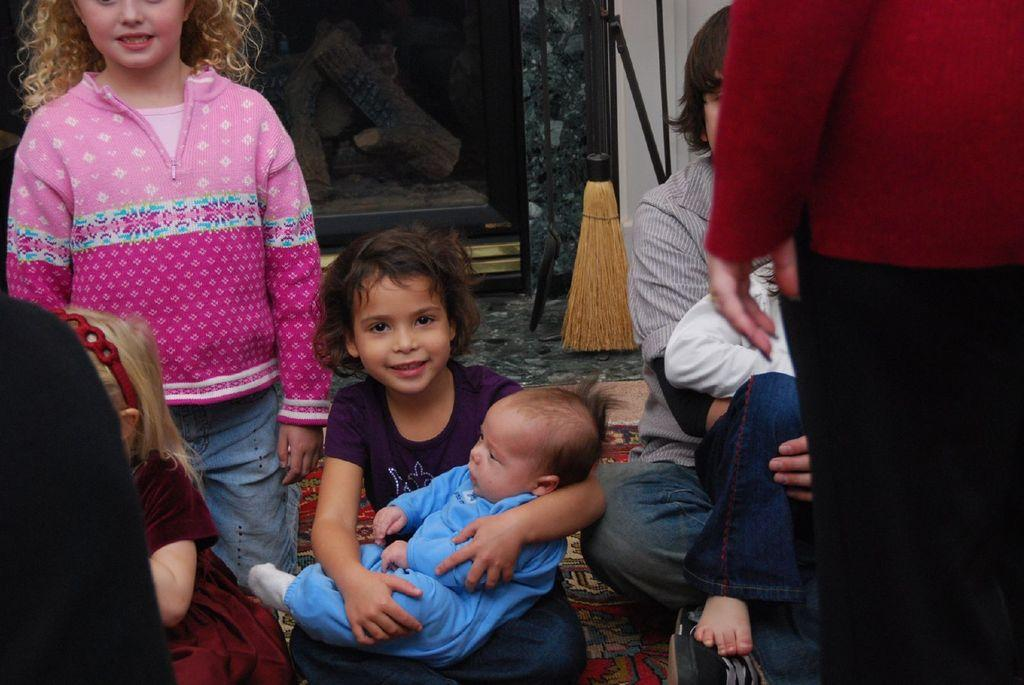How many people are in the image? There are persons in the image. What is the woman doing with the baby? The woman is holding a baby with her hands. Where is the scene taking place? The scene is on the floor. What can be seen in the background of the image? There is a wooden oven in the background of the image. What month is it in the image? The provided facts do not mention any specific month, so it cannot be determined from the image. --- Facts: 1. There is a car in the image. 2. The car is red. 3. The car has four wheels. 4. There is a road in the image. 5. The road is paved. Absurd Topics: bird, ocean, mountain Conversation: What is the main subject of the image? The main subject of the image is a car. What color is the car? The car is red. How many wheels does the car have? The car has four wheels. What can be seen in the background of the image? There is a road in the image. What is the condition of the road? The road is paved. Reasoning: Let's think step by step in order to produce the conversation. We start by identifying the main subject of the image, which is the car. Then, we describe the color and number of wheels of the car. Next, we mention the presence of a road in the background, which provides context about the setting. Finally, we specify the condition of the road, which is paved. Absurd Question/Answer: Can you see any birds flying over the ocean in the image? There is no mention of birds, ocean, or mountains in the provided facts, so it cannot be determined from the image. 